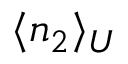Convert formula to latex. <formula><loc_0><loc_0><loc_500><loc_500>\langle n _ { 2 } \rangle _ { U }</formula> 